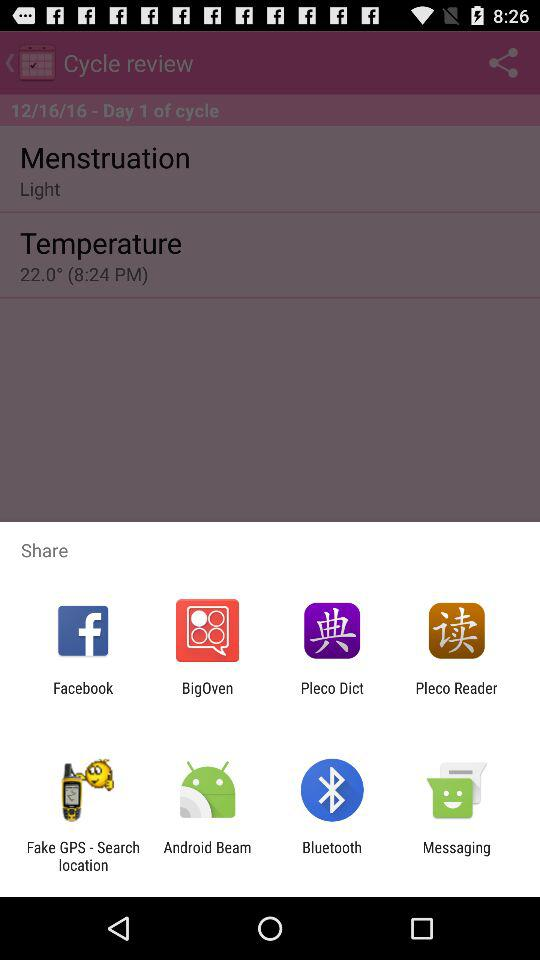What are the sharing applications through which I can share? The sharing applications through which you can share are "Facebook", "BigOven", "Pleco Dict", "Pleco Reader", "Fake GPS - Search location", "Android Beam", "Bluetooth" and "Messaging". 